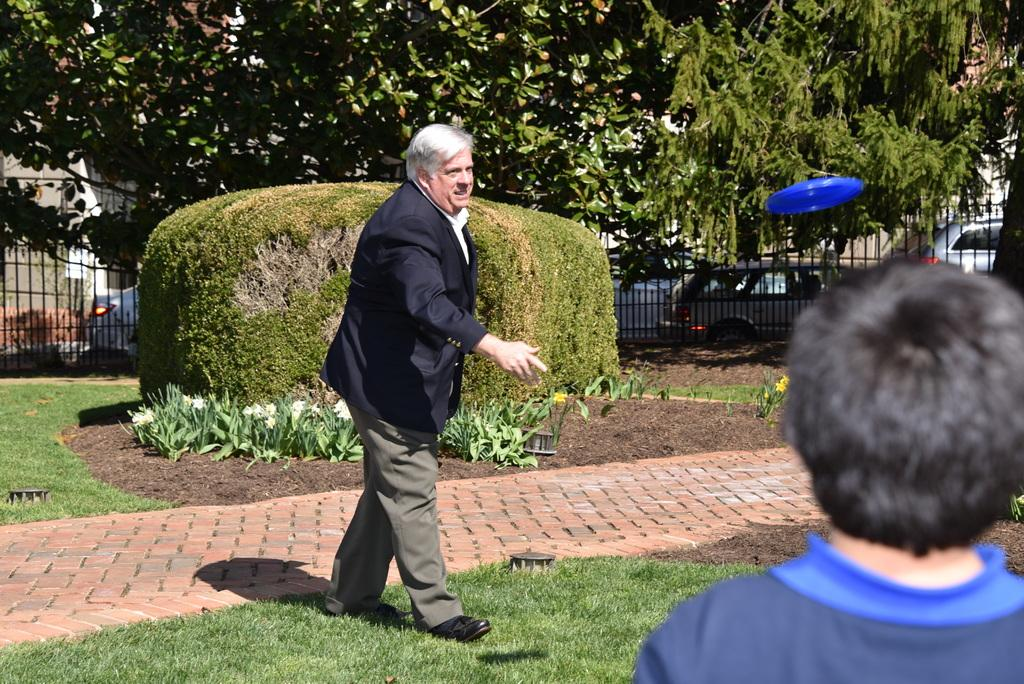How many people are in the foreground of the image? There are two persons on the ground in the foreground. What can be seen in the background of the image? In the background, there are plants, a fence, a disc, trees, and fleets of cars on the road. What type of location is depicted in the image? The image is taken in a park. How many parcels are being delivered to the persons in the image? There is no mention of parcels or delivery in the image. What type of cork can be seen in the image? There is no cork present in the image. 